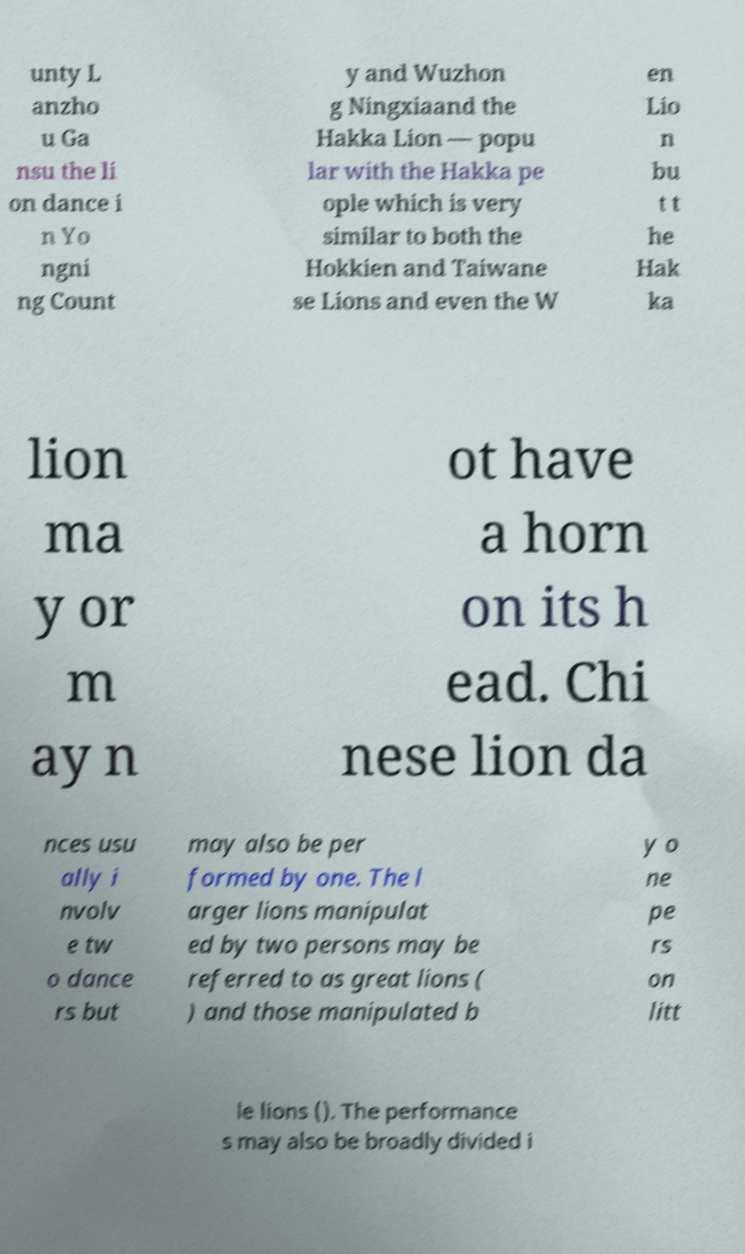Can you read and provide the text displayed in the image?This photo seems to have some interesting text. Can you extract and type it out for me? unty L anzho u Ga nsu the li on dance i n Yo ngni ng Count y and Wuzhon g Ningxiaand the Hakka Lion — popu lar with the Hakka pe ople which is very similar to both the Hokkien and Taiwane se Lions and even the W en Lio n bu t t he Hak ka lion ma y or m ay n ot have a horn on its h ead. Chi nese lion da nces usu ally i nvolv e tw o dance rs but may also be per formed by one. The l arger lions manipulat ed by two persons may be referred to as great lions ( ) and those manipulated b y o ne pe rs on litt le lions (). The performance s may also be broadly divided i 